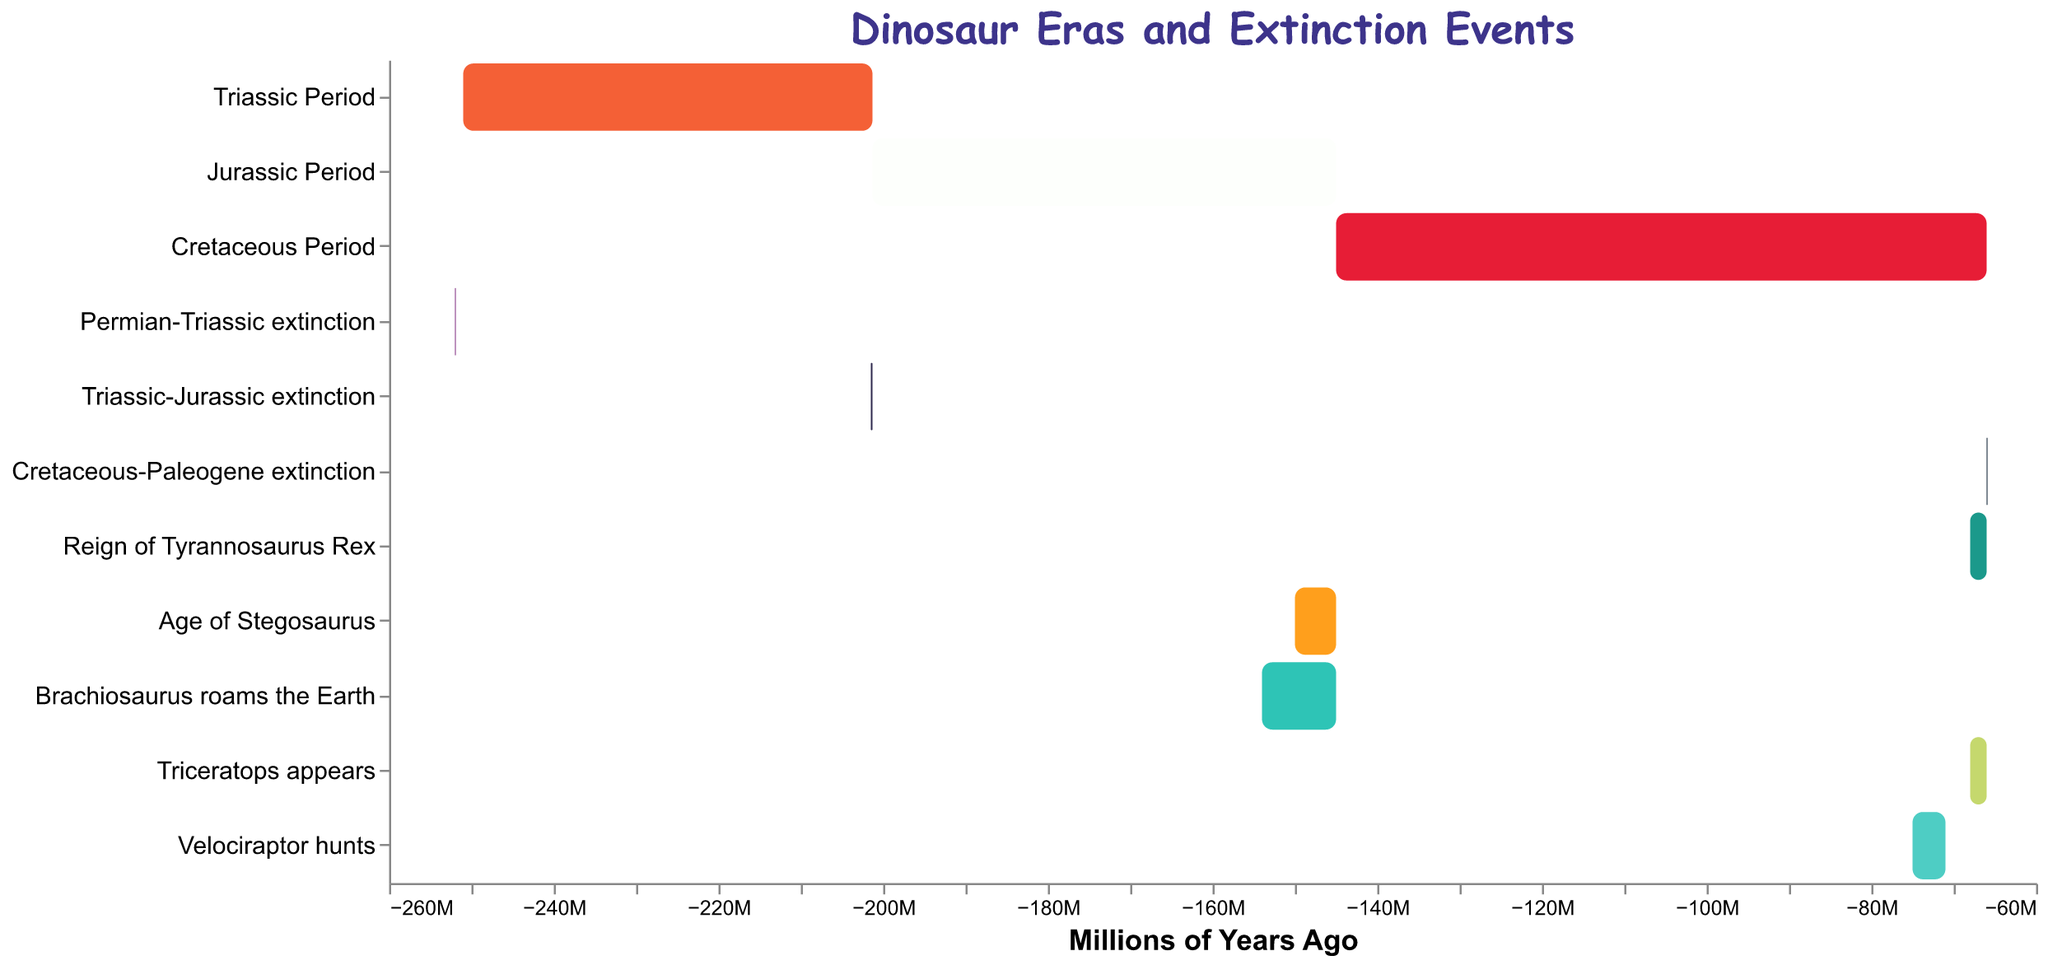What is the title of the chart? The title of the chart is located at the top and is in a larger font size, indicating the main topic of the chart. This helps us quickly identify what the chart is about.
Answer: Dinosaur Eras and Extinction Events How long did the Triassic Period last? To find the duration of the Triassic Period, subtract the start time from the end time (251,000,000 - 201,300,000 = 49,700,000 years).
Answer: 49,700,000 years Which period lasted longer, the Jurassic or the Cretaceous? Calculate the durations of both periods first. Jurassic: 201,300,000 - 145,000,000 = 56,300,000 years. Cretaceous: 145,000,000 - 66,000,000 = 79,000,000 years. By comparing, the Cretaceous lasted longer.
Answer: Cretaceous During which event did the Tyrannosaurus Rex exist? Tyrannosaurus Rex existed from 68,000,000 to 66,000,000 years ago. Check the timeline overlap to see which extinction event happens within this range. The Cretaceous-Paleogene extinction spans from 66,000,000 to 65,900,000 years ago, which overlaps with the reign of the Tyrannosaurus Rex.
Answer: Cretaceous-Paleogene extinction How many major extinction events are shown on the chart? Reviewing the chart, we can count the distinct bars labeled as extinction events (Permian-Triassic, Triassic-Jurassic, Cretaceous-Paleogene).
Answer: 3 Which dinosaur's timeline overlaps with the Jurassic Period? Identify the timelines of dinosaurs and check if any overlap with the Jurassic Period (201,300,000 to 145,000,000 years). Both "Age of Stegosaurus" starting at 150,000,000 and "Brachiosaurus roams the Earth" starting at 154,000,000 overlap with the Jurassic.
Answer: Stegosaurus and Brachiosaurus How long did the Reign of Tyrannosaurus Rex last? Subtract the start of the Tyrannosaurus Rex timeline from its end (68,000,000 - 66,000,000 = 2,000,000 years).
Answer: 2,000,000 years What is the time gap between the Triassic-Jurassic extinction and the beginning of the Jurassic Period? Find the end of the Triassic-Jurassic extinction and the start of the Jurassic period. Both are at 201,300,000 years ago, so there is no gap.
Answer: 0 years Which event occurred first, Triceratops appearing or the Velociraptor hunting? Compare the start times of both events. Velociraptor (75,000,000 years ago) and Triceratops (68,000,000 years ago) indicate that Velociraptor hunted first.
Answer: Velociraptor hunting What color is used to represent the Cretaceous Period on the chart? Identify the Cretaceous Period in the chart and check its corresponding color. The Cretaceous Period is the third timeline from the top and is colored red.
Answer: Red 